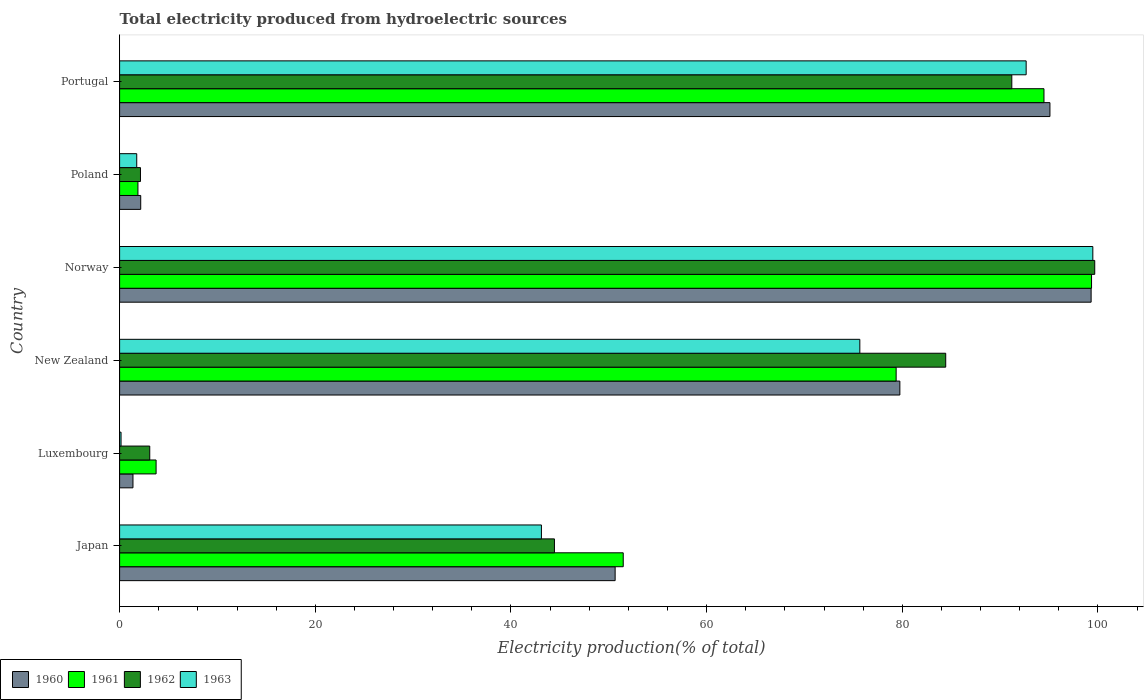How many different coloured bars are there?
Give a very brief answer. 4. How many bars are there on the 1st tick from the bottom?
Offer a very short reply. 4. What is the total electricity produced in 1960 in New Zealand?
Make the answer very short. 79.75. Across all countries, what is the maximum total electricity produced in 1961?
Keep it short and to the point. 99.34. Across all countries, what is the minimum total electricity produced in 1963?
Provide a succinct answer. 0.15. In which country was the total electricity produced in 1963 minimum?
Provide a succinct answer. Luxembourg. What is the total total electricity produced in 1960 in the graph?
Provide a short and direct response. 328.31. What is the difference between the total electricity produced in 1960 in New Zealand and that in Portugal?
Your response must be concise. -15.34. What is the difference between the total electricity produced in 1960 in Luxembourg and the total electricity produced in 1961 in Norway?
Make the answer very short. -97.98. What is the average total electricity produced in 1963 per country?
Offer a very short reply. 52.13. What is the difference between the total electricity produced in 1960 and total electricity produced in 1961 in Poland?
Your answer should be very brief. 0.28. In how many countries, is the total electricity produced in 1961 greater than 52 %?
Keep it short and to the point. 3. What is the ratio of the total electricity produced in 1962 in Japan to that in New Zealand?
Provide a short and direct response. 0.53. Is the difference between the total electricity produced in 1960 in Poland and Portugal greater than the difference between the total electricity produced in 1961 in Poland and Portugal?
Ensure brevity in your answer.  No. What is the difference between the highest and the second highest total electricity produced in 1962?
Offer a terse response. 8.48. What is the difference between the highest and the lowest total electricity produced in 1960?
Your response must be concise. 97.93. Are all the bars in the graph horizontal?
Provide a succinct answer. Yes. What is the difference between two consecutive major ticks on the X-axis?
Make the answer very short. 20. Are the values on the major ticks of X-axis written in scientific E-notation?
Keep it short and to the point. No. How many legend labels are there?
Your response must be concise. 4. How are the legend labels stacked?
Make the answer very short. Horizontal. What is the title of the graph?
Offer a terse response. Total electricity produced from hydroelectric sources. Does "1983" appear as one of the legend labels in the graph?
Offer a terse response. No. What is the label or title of the X-axis?
Ensure brevity in your answer.  Electricity production(% of total). What is the Electricity production(% of total) of 1960 in Japan?
Your answer should be compact. 50.65. What is the Electricity production(% of total) in 1961 in Japan?
Your response must be concise. 51.48. What is the Electricity production(% of total) in 1962 in Japan?
Give a very brief answer. 44.44. What is the Electricity production(% of total) of 1963 in Japan?
Give a very brief answer. 43.11. What is the Electricity production(% of total) of 1960 in Luxembourg?
Give a very brief answer. 1.37. What is the Electricity production(% of total) in 1961 in Luxembourg?
Your response must be concise. 3.73. What is the Electricity production(% of total) in 1962 in Luxembourg?
Keep it short and to the point. 3.08. What is the Electricity production(% of total) of 1963 in Luxembourg?
Provide a short and direct response. 0.15. What is the Electricity production(% of total) in 1960 in New Zealand?
Make the answer very short. 79.75. What is the Electricity production(% of total) in 1961 in New Zealand?
Your response must be concise. 79.37. What is the Electricity production(% of total) of 1962 in New Zealand?
Ensure brevity in your answer.  84.44. What is the Electricity production(% of total) in 1963 in New Zealand?
Offer a terse response. 75.66. What is the Electricity production(% of total) of 1960 in Norway?
Your answer should be compact. 99.3. What is the Electricity production(% of total) in 1961 in Norway?
Keep it short and to the point. 99.34. What is the Electricity production(% of total) of 1962 in Norway?
Provide a succinct answer. 99.67. What is the Electricity production(% of total) of 1963 in Norway?
Provide a short and direct response. 99.47. What is the Electricity production(% of total) of 1960 in Poland?
Make the answer very short. 2.16. What is the Electricity production(% of total) in 1961 in Poland?
Give a very brief answer. 1.87. What is the Electricity production(% of total) of 1962 in Poland?
Offer a terse response. 2.13. What is the Electricity production(% of total) of 1963 in Poland?
Your answer should be compact. 1.75. What is the Electricity production(% of total) of 1960 in Portugal?
Offer a very short reply. 95.09. What is the Electricity production(% of total) of 1961 in Portugal?
Keep it short and to the point. 94.48. What is the Electricity production(% of total) in 1962 in Portugal?
Give a very brief answer. 91.19. What is the Electricity production(% of total) of 1963 in Portugal?
Offer a terse response. 92.66. Across all countries, what is the maximum Electricity production(% of total) in 1960?
Your answer should be very brief. 99.3. Across all countries, what is the maximum Electricity production(% of total) of 1961?
Make the answer very short. 99.34. Across all countries, what is the maximum Electricity production(% of total) in 1962?
Your answer should be compact. 99.67. Across all countries, what is the maximum Electricity production(% of total) of 1963?
Provide a short and direct response. 99.47. Across all countries, what is the minimum Electricity production(% of total) of 1960?
Your answer should be very brief. 1.37. Across all countries, what is the minimum Electricity production(% of total) in 1961?
Your answer should be compact. 1.87. Across all countries, what is the minimum Electricity production(% of total) in 1962?
Provide a short and direct response. 2.13. Across all countries, what is the minimum Electricity production(% of total) in 1963?
Provide a short and direct response. 0.15. What is the total Electricity production(% of total) in 1960 in the graph?
Your answer should be compact. 328.31. What is the total Electricity production(% of total) of 1961 in the graph?
Keep it short and to the point. 330.28. What is the total Electricity production(% of total) of 1962 in the graph?
Give a very brief answer. 324.96. What is the total Electricity production(% of total) of 1963 in the graph?
Provide a succinct answer. 312.81. What is the difference between the Electricity production(% of total) of 1960 in Japan and that in Luxembourg?
Give a very brief answer. 49.28. What is the difference between the Electricity production(% of total) in 1961 in Japan and that in Luxembourg?
Give a very brief answer. 47.75. What is the difference between the Electricity production(% of total) of 1962 in Japan and that in Luxembourg?
Offer a terse response. 41.36. What is the difference between the Electricity production(% of total) in 1963 in Japan and that in Luxembourg?
Make the answer very short. 42.97. What is the difference between the Electricity production(% of total) in 1960 in Japan and that in New Zealand?
Give a very brief answer. -29.1. What is the difference between the Electricity production(% of total) of 1961 in Japan and that in New Zealand?
Provide a short and direct response. -27.9. What is the difference between the Electricity production(% of total) in 1962 in Japan and that in New Zealand?
Provide a succinct answer. -39.99. What is the difference between the Electricity production(% of total) in 1963 in Japan and that in New Zealand?
Offer a very short reply. -32.54. What is the difference between the Electricity production(% of total) of 1960 in Japan and that in Norway?
Your answer should be compact. -48.65. What is the difference between the Electricity production(% of total) in 1961 in Japan and that in Norway?
Ensure brevity in your answer.  -47.87. What is the difference between the Electricity production(% of total) of 1962 in Japan and that in Norway?
Provide a short and direct response. -55.23. What is the difference between the Electricity production(% of total) in 1963 in Japan and that in Norway?
Ensure brevity in your answer.  -56.36. What is the difference between the Electricity production(% of total) in 1960 in Japan and that in Poland?
Ensure brevity in your answer.  48.49. What is the difference between the Electricity production(% of total) in 1961 in Japan and that in Poland?
Offer a terse response. 49.6. What is the difference between the Electricity production(% of total) in 1962 in Japan and that in Poland?
Offer a terse response. 42.31. What is the difference between the Electricity production(% of total) of 1963 in Japan and that in Poland?
Give a very brief answer. 41.36. What is the difference between the Electricity production(% of total) of 1960 in Japan and that in Portugal?
Give a very brief answer. -44.44. What is the difference between the Electricity production(% of total) in 1961 in Japan and that in Portugal?
Offer a terse response. -43. What is the difference between the Electricity production(% of total) of 1962 in Japan and that in Portugal?
Offer a terse response. -46.75. What is the difference between the Electricity production(% of total) in 1963 in Japan and that in Portugal?
Your answer should be compact. -49.55. What is the difference between the Electricity production(% of total) of 1960 in Luxembourg and that in New Zealand?
Provide a short and direct response. -78.38. What is the difference between the Electricity production(% of total) of 1961 in Luxembourg and that in New Zealand?
Offer a terse response. -75.64. What is the difference between the Electricity production(% of total) in 1962 in Luxembourg and that in New Zealand?
Provide a succinct answer. -81.36. What is the difference between the Electricity production(% of total) in 1963 in Luxembourg and that in New Zealand?
Ensure brevity in your answer.  -75.51. What is the difference between the Electricity production(% of total) in 1960 in Luxembourg and that in Norway?
Provide a succinct answer. -97.93. What is the difference between the Electricity production(% of total) of 1961 in Luxembourg and that in Norway?
Offer a terse response. -95.61. What is the difference between the Electricity production(% of total) in 1962 in Luxembourg and that in Norway?
Your answer should be very brief. -96.59. What is the difference between the Electricity production(% of total) of 1963 in Luxembourg and that in Norway?
Offer a terse response. -99.33. What is the difference between the Electricity production(% of total) in 1960 in Luxembourg and that in Poland?
Your response must be concise. -0.79. What is the difference between the Electricity production(% of total) in 1961 in Luxembourg and that in Poland?
Ensure brevity in your answer.  1.86. What is the difference between the Electricity production(% of total) of 1962 in Luxembourg and that in Poland?
Provide a succinct answer. 0.95. What is the difference between the Electricity production(% of total) in 1963 in Luxembourg and that in Poland?
Ensure brevity in your answer.  -1.6. What is the difference between the Electricity production(% of total) of 1960 in Luxembourg and that in Portugal?
Your answer should be very brief. -93.72. What is the difference between the Electricity production(% of total) in 1961 in Luxembourg and that in Portugal?
Offer a very short reply. -90.75. What is the difference between the Electricity production(% of total) of 1962 in Luxembourg and that in Portugal?
Offer a very short reply. -88.11. What is the difference between the Electricity production(% of total) of 1963 in Luxembourg and that in Portugal?
Offer a terse response. -92.51. What is the difference between the Electricity production(% of total) in 1960 in New Zealand and that in Norway?
Your answer should be very brief. -19.55. What is the difference between the Electricity production(% of total) in 1961 in New Zealand and that in Norway?
Provide a short and direct response. -19.97. What is the difference between the Electricity production(% of total) in 1962 in New Zealand and that in Norway?
Offer a terse response. -15.23. What is the difference between the Electricity production(% of total) in 1963 in New Zealand and that in Norway?
Your answer should be very brief. -23.82. What is the difference between the Electricity production(% of total) in 1960 in New Zealand and that in Poland?
Your response must be concise. 77.59. What is the difference between the Electricity production(% of total) in 1961 in New Zealand and that in Poland?
Ensure brevity in your answer.  77.5. What is the difference between the Electricity production(% of total) of 1962 in New Zealand and that in Poland?
Keep it short and to the point. 82.31. What is the difference between the Electricity production(% of total) in 1963 in New Zealand and that in Poland?
Provide a succinct answer. 73.91. What is the difference between the Electricity production(% of total) of 1960 in New Zealand and that in Portugal?
Offer a terse response. -15.34. What is the difference between the Electricity production(% of total) in 1961 in New Zealand and that in Portugal?
Make the answer very short. -15.11. What is the difference between the Electricity production(% of total) of 1962 in New Zealand and that in Portugal?
Ensure brevity in your answer.  -6.75. What is the difference between the Electricity production(% of total) in 1963 in New Zealand and that in Portugal?
Your answer should be very brief. -17. What is the difference between the Electricity production(% of total) in 1960 in Norway and that in Poland?
Provide a succinct answer. 97.14. What is the difference between the Electricity production(% of total) of 1961 in Norway and that in Poland?
Provide a succinct answer. 97.47. What is the difference between the Electricity production(% of total) of 1962 in Norway and that in Poland?
Keep it short and to the point. 97.54. What is the difference between the Electricity production(% of total) of 1963 in Norway and that in Poland?
Provide a short and direct response. 97.72. What is the difference between the Electricity production(% of total) of 1960 in Norway and that in Portugal?
Offer a very short reply. 4.21. What is the difference between the Electricity production(% of total) of 1961 in Norway and that in Portugal?
Make the answer very short. 4.86. What is the difference between the Electricity production(% of total) in 1962 in Norway and that in Portugal?
Your answer should be compact. 8.48. What is the difference between the Electricity production(% of total) of 1963 in Norway and that in Portugal?
Keep it short and to the point. 6.81. What is the difference between the Electricity production(% of total) of 1960 in Poland and that in Portugal?
Your answer should be compact. -92.93. What is the difference between the Electricity production(% of total) in 1961 in Poland and that in Portugal?
Your response must be concise. -92.61. What is the difference between the Electricity production(% of total) in 1962 in Poland and that in Portugal?
Your response must be concise. -89.06. What is the difference between the Electricity production(% of total) in 1963 in Poland and that in Portugal?
Keep it short and to the point. -90.91. What is the difference between the Electricity production(% of total) of 1960 in Japan and the Electricity production(% of total) of 1961 in Luxembourg?
Provide a short and direct response. 46.92. What is the difference between the Electricity production(% of total) of 1960 in Japan and the Electricity production(% of total) of 1962 in Luxembourg?
Your response must be concise. 47.57. What is the difference between the Electricity production(% of total) of 1960 in Japan and the Electricity production(% of total) of 1963 in Luxembourg?
Your answer should be very brief. 50.5. What is the difference between the Electricity production(% of total) of 1961 in Japan and the Electricity production(% of total) of 1962 in Luxembourg?
Keep it short and to the point. 48.39. What is the difference between the Electricity production(% of total) in 1961 in Japan and the Electricity production(% of total) in 1963 in Luxembourg?
Provide a succinct answer. 51.33. What is the difference between the Electricity production(% of total) in 1962 in Japan and the Electricity production(% of total) in 1963 in Luxembourg?
Make the answer very short. 44.3. What is the difference between the Electricity production(% of total) of 1960 in Japan and the Electricity production(% of total) of 1961 in New Zealand?
Your answer should be compact. -28.72. What is the difference between the Electricity production(% of total) in 1960 in Japan and the Electricity production(% of total) in 1962 in New Zealand?
Keep it short and to the point. -33.79. What is the difference between the Electricity production(% of total) of 1960 in Japan and the Electricity production(% of total) of 1963 in New Zealand?
Your answer should be compact. -25.01. What is the difference between the Electricity production(% of total) of 1961 in Japan and the Electricity production(% of total) of 1962 in New Zealand?
Offer a very short reply. -32.96. What is the difference between the Electricity production(% of total) in 1961 in Japan and the Electricity production(% of total) in 1963 in New Zealand?
Offer a very short reply. -24.18. What is the difference between the Electricity production(% of total) in 1962 in Japan and the Electricity production(% of total) in 1963 in New Zealand?
Give a very brief answer. -31.21. What is the difference between the Electricity production(% of total) in 1960 in Japan and the Electricity production(% of total) in 1961 in Norway?
Your answer should be compact. -48.69. What is the difference between the Electricity production(% of total) of 1960 in Japan and the Electricity production(% of total) of 1962 in Norway?
Ensure brevity in your answer.  -49.02. What is the difference between the Electricity production(% of total) in 1960 in Japan and the Electricity production(% of total) in 1963 in Norway?
Provide a short and direct response. -48.83. What is the difference between the Electricity production(% of total) in 1961 in Japan and the Electricity production(% of total) in 1962 in Norway?
Ensure brevity in your answer.  -48.19. What is the difference between the Electricity production(% of total) in 1961 in Japan and the Electricity production(% of total) in 1963 in Norway?
Give a very brief answer. -48. What is the difference between the Electricity production(% of total) of 1962 in Japan and the Electricity production(% of total) of 1963 in Norway?
Your response must be concise. -55.03. What is the difference between the Electricity production(% of total) in 1960 in Japan and the Electricity production(% of total) in 1961 in Poland?
Offer a very short reply. 48.78. What is the difference between the Electricity production(% of total) of 1960 in Japan and the Electricity production(% of total) of 1962 in Poland?
Keep it short and to the point. 48.52. What is the difference between the Electricity production(% of total) in 1960 in Japan and the Electricity production(% of total) in 1963 in Poland?
Provide a succinct answer. 48.9. What is the difference between the Electricity production(% of total) of 1961 in Japan and the Electricity production(% of total) of 1962 in Poland?
Your response must be concise. 49.34. What is the difference between the Electricity production(% of total) of 1961 in Japan and the Electricity production(% of total) of 1963 in Poland?
Provide a succinct answer. 49.72. What is the difference between the Electricity production(% of total) of 1962 in Japan and the Electricity production(% of total) of 1963 in Poland?
Provide a short and direct response. 42.69. What is the difference between the Electricity production(% of total) of 1960 in Japan and the Electricity production(% of total) of 1961 in Portugal?
Provide a short and direct response. -43.83. What is the difference between the Electricity production(% of total) of 1960 in Japan and the Electricity production(% of total) of 1962 in Portugal?
Make the answer very short. -40.54. What is the difference between the Electricity production(% of total) in 1960 in Japan and the Electricity production(% of total) in 1963 in Portugal?
Give a very brief answer. -42.01. What is the difference between the Electricity production(% of total) in 1961 in Japan and the Electricity production(% of total) in 1962 in Portugal?
Make the answer very short. -39.72. What is the difference between the Electricity production(% of total) in 1961 in Japan and the Electricity production(% of total) in 1963 in Portugal?
Provide a short and direct response. -41.18. What is the difference between the Electricity production(% of total) of 1962 in Japan and the Electricity production(% of total) of 1963 in Portugal?
Provide a short and direct response. -48.22. What is the difference between the Electricity production(% of total) in 1960 in Luxembourg and the Electricity production(% of total) in 1961 in New Zealand?
Ensure brevity in your answer.  -78.01. What is the difference between the Electricity production(% of total) in 1960 in Luxembourg and the Electricity production(% of total) in 1962 in New Zealand?
Provide a succinct answer. -83.07. What is the difference between the Electricity production(% of total) in 1960 in Luxembourg and the Electricity production(% of total) in 1963 in New Zealand?
Provide a succinct answer. -74.29. What is the difference between the Electricity production(% of total) in 1961 in Luxembourg and the Electricity production(% of total) in 1962 in New Zealand?
Offer a terse response. -80.71. What is the difference between the Electricity production(% of total) of 1961 in Luxembourg and the Electricity production(% of total) of 1963 in New Zealand?
Offer a terse response. -71.93. What is the difference between the Electricity production(% of total) in 1962 in Luxembourg and the Electricity production(% of total) in 1963 in New Zealand?
Offer a terse response. -72.58. What is the difference between the Electricity production(% of total) in 1960 in Luxembourg and the Electricity production(% of total) in 1961 in Norway?
Keep it short and to the point. -97.98. What is the difference between the Electricity production(% of total) of 1960 in Luxembourg and the Electricity production(% of total) of 1962 in Norway?
Make the answer very short. -98.3. What is the difference between the Electricity production(% of total) of 1960 in Luxembourg and the Electricity production(% of total) of 1963 in Norway?
Your answer should be very brief. -98.11. What is the difference between the Electricity production(% of total) of 1961 in Luxembourg and the Electricity production(% of total) of 1962 in Norway?
Provide a short and direct response. -95.94. What is the difference between the Electricity production(% of total) in 1961 in Luxembourg and the Electricity production(% of total) in 1963 in Norway?
Offer a terse response. -95.74. What is the difference between the Electricity production(% of total) in 1962 in Luxembourg and the Electricity production(% of total) in 1963 in Norway?
Your answer should be very brief. -96.39. What is the difference between the Electricity production(% of total) in 1960 in Luxembourg and the Electricity production(% of total) in 1961 in Poland?
Your answer should be compact. -0.51. What is the difference between the Electricity production(% of total) of 1960 in Luxembourg and the Electricity production(% of total) of 1962 in Poland?
Provide a succinct answer. -0.77. What is the difference between the Electricity production(% of total) of 1960 in Luxembourg and the Electricity production(% of total) of 1963 in Poland?
Ensure brevity in your answer.  -0.39. What is the difference between the Electricity production(% of total) in 1961 in Luxembourg and the Electricity production(% of total) in 1962 in Poland?
Your answer should be compact. 1.6. What is the difference between the Electricity production(% of total) in 1961 in Luxembourg and the Electricity production(% of total) in 1963 in Poland?
Make the answer very short. 1.98. What is the difference between the Electricity production(% of total) of 1962 in Luxembourg and the Electricity production(% of total) of 1963 in Poland?
Offer a terse response. 1.33. What is the difference between the Electricity production(% of total) of 1960 in Luxembourg and the Electricity production(% of total) of 1961 in Portugal?
Provide a short and direct response. -93.11. What is the difference between the Electricity production(% of total) of 1960 in Luxembourg and the Electricity production(% of total) of 1962 in Portugal?
Provide a short and direct response. -89.83. What is the difference between the Electricity production(% of total) in 1960 in Luxembourg and the Electricity production(% of total) in 1963 in Portugal?
Offer a very short reply. -91.29. What is the difference between the Electricity production(% of total) of 1961 in Luxembourg and the Electricity production(% of total) of 1962 in Portugal?
Give a very brief answer. -87.46. What is the difference between the Electricity production(% of total) in 1961 in Luxembourg and the Electricity production(% of total) in 1963 in Portugal?
Offer a terse response. -88.93. What is the difference between the Electricity production(% of total) of 1962 in Luxembourg and the Electricity production(% of total) of 1963 in Portugal?
Your response must be concise. -89.58. What is the difference between the Electricity production(% of total) of 1960 in New Zealand and the Electricity production(% of total) of 1961 in Norway?
Your answer should be very brief. -19.59. What is the difference between the Electricity production(% of total) of 1960 in New Zealand and the Electricity production(% of total) of 1962 in Norway?
Ensure brevity in your answer.  -19.92. What is the difference between the Electricity production(% of total) of 1960 in New Zealand and the Electricity production(% of total) of 1963 in Norway?
Your answer should be very brief. -19.72. What is the difference between the Electricity production(% of total) in 1961 in New Zealand and the Electricity production(% of total) in 1962 in Norway?
Provide a succinct answer. -20.3. What is the difference between the Electricity production(% of total) in 1961 in New Zealand and the Electricity production(% of total) in 1963 in Norway?
Ensure brevity in your answer.  -20.1. What is the difference between the Electricity production(% of total) in 1962 in New Zealand and the Electricity production(% of total) in 1963 in Norway?
Offer a terse response. -15.04. What is the difference between the Electricity production(% of total) in 1960 in New Zealand and the Electricity production(% of total) in 1961 in Poland?
Keep it short and to the point. 77.88. What is the difference between the Electricity production(% of total) of 1960 in New Zealand and the Electricity production(% of total) of 1962 in Poland?
Provide a succinct answer. 77.62. What is the difference between the Electricity production(% of total) in 1960 in New Zealand and the Electricity production(% of total) in 1963 in Poland?
Offer a terse response. 78. What is the difference between the Electricity production(% of total) of 1961 in New Zealand and the Electricity production(% of total) of 1962 in Poland?
Make the answer very short. 77.24. What is the difference between the Electricity production(% of total) of 1961 in New Zealand and the Electricity production(% of total) of 1963 in Poland?
Give a very brief answer. 77.62. What is the difference between the Electricity production(% of total) of 1962 in New Zealand and the Electricity production(% of total) of 1963 in Poland?
Your answer should be compact. 82.69. What is the difference between the Electricity production(% of total) in 1960 in New Zealand and the Electricity production(% of total) in 1961 in Portugal?
Make the answer very short. -14.73. What is the difference between the Electricity production(% of total) of 1960 in New Zealand and the Electricity production(% of total) of 1962 in Portugal?
Your answer should be very brief. -11.44. What is the difference between the Electricity production(% of total) of 1960 in New Zealand and the Electricity production(% of total) of 1963 in Portugal?
Your response must be concise. -12.91. What is the difference between the Electricity production(% of total) of 1961 in New Zealand and the Electricity production(% of total) of 1962 in Portugal?
Provide a short and direct response. -11.82. What is the difference between the Electricity production(% of total) of 1961 in New Zealand and the Electricity production(% of total) of 1963 in Portugal?
Your response must be concise. -13.29. What is the difference between the Electricity production(% of total) in 1962 in New Zealand and the Electricity production(% of total) in 1963 in Portugal?
Offer a very short reply. -8.22. What is the difference between the Electricity production(% of total) in 1960 in Norway and the Electricity production(% of total) in 1961 in Poland?
Provide a succinct answer. 97.43. What is the difference between the Electricity production(% of total) of 1960 in Norway and the Electricity production(% of total) of 1962 in Poland?
Offer a terse response. 97.17. What is the difference between the Electricity production(% of total) in 1960 in Norway and the Electricity production(% of total) in 1963 in Poland?
Ensure brevity in your answer.  97.55. What is the difference between the Electricity production(% of total) in 1961 in Norway and the Electricity production(% of total) in 1962 in Poland?
Make the answer very short. 97.21. What is the difference between the Electricity production(% of total) of 1961 in Norway and the Electricity production(% of total) of 1963 in Poland?
Provide a succinct answer. 97.59. What is the difference between the Electricity production(% of total) of 1962 in Norway and the Electricity production(% of total) of 1963 in Poland?
Your response must be concise. 97.92. What is the difference between the Electricity production(% of total) in 1960 in Norway and the Electricity production(% of total) in 1961 in Portugal?
Keep it short and to the point. 4.82. What is the difference between the Electricity production(% of total) in 1960 in Norway and the Electricity production(% of total) in 1962 in Portugal?
Your answer should be very brief. 8.11. What is the difference between the Electricity production(% of total) in 1960 in Norway and the Electricity production(% of total) in 1963 in Portugal?
Ensure brevity in your answer.  6.64. What is the difference between the Electricity production(% of total) of 1961 in Norway and the Electricity production(% of total) of 1962 in Portugal?
Keep it short and to the point. 8.15. What is the difference between the Electricity production(% of total) of 1961 in Norway and the Electricity production(% of total) of 1963 in Portugal?
Give a very brief answer. 6.68. What is the difference between the Electricity production(% of total) in 1962 in Norway and the Electricity production(% of total) in 1963 in Portugal?
Give a very brief answer. 7.01. What is the difference between the Electricity production(% of total) of 1960 in Poland and the Electricity production(% of total) of 1961 in Portugal?
Provide a succinct answer. -92.32. What is the difference between the Electricity production(% of total) of 1960 in Poland and the Electricity production(% of total) of 1962 in Portugal?
Make the answer very short. -89.03. What is the difference between the Electricity production(% of total) in 1960 in Poland and the Electricity production(% of total) in 1963 in Portugal?
Offer a terse response. -90.5. What is the difference between the Electricity production(% of total) of 1961 in Poland and the Electricity production(% of total) of 1962 in Portugal?
Make the answer very short. -89.32. What is the difference between the Electricity production(% of total) of 1961 in Poland and the Electricity production(% of total) of 1963 in Portugal?
Offer a very short reply. -90.79. What is the difference between the Electricity production(% of total) of 1962 in Poland and the Electricity production(% of total) of 1963 in Portugal?
Your answer should be very brief. -90.53. What is the average Electricity production(% of total) in 1960 per country?
Make the answer very short. 54.72. What is the average Electricity production(% of total) in 1961 per country?
Give a very brief answer. 55.05. What is the average Electricity production(% of total) of 1962 per country?
Offer a terse response. 54.16. What is the average Electricity production(% of total) of 1963 per country?
Offer a terse response. 52.13. What is the difference between the Electricity production(% of total) of 1960 and Electricity production(% of total) of 1961 in Japan?
Provide a succinct answer. -0.83. What is the difference between the Electricity production(% of total) in 1960 and Electricity production(% of total) in 1962 in Japan?
Give a very brief answer. 6.2. What is the difference between the Electricity production(% of total) of 1960 and Electricity production(% of total) of 1963 in Japan?
Offer a terse response. 7.54. What is the difference between the Electricity production(% of total) in 1961 and Electricity production(% of total) in 1962 in Japan?
Ensure brevity in your answer.  7.03. What is the difference between the Electricity production(% of total) in 1961 and Electricity production(% of total) in 1963 in Japan?
Your response must be concise. 8.36. What is the difference between the Electricity production(% of total) of 1962 and Electricity production(% of total) of 1963 in Japan?
Give a very brief answer. 1.33. What is the difference between the Electricity production(% of total) in 1960 and Electricity production(% of total) in 1961 in Luxembourg?
Provide a succinct answer. -2.36. What is the difference between the Electricity production(% of total) of 1960 and Electricity production(% of total) of 1962 in Luxembourg?
Ensure brevity in your answer.  -1.72. What is the difference between the Electricity production(% of total) in 1960 and Electricity production(% of total) in 1963 in Luxembourg?
Provide a short and direct response. 1.22. What is the difference between the Electricity production(% of total) in 1961 and Electricity production(% of total) in 1962 in Luxembourg?
Your response must be concise. 0.65. What is the difference between the Electricity production(% of total) in 1961 and Electricity production(% of total) in 1963 in Luxembourg?
Keep it short and to the point. 3.58. What is the difference between the Electricity production(% of total) of 1962 and Electricity production(% of total) of 1963 in Luxembourg?
Your answer should be very brief. 2.93. What is the difference between the Electricity production(% of total) in 1960 and Electricity production(% of total) in 1961 in New Zealand?
Ensure brevity in your answer.  0.38. What is the difference between the Electricity production(% of total) in 1960 and Electricity production(% of total) in 1962 in New Zealand?
Provide a short and direct response. -4.69. What is the difference between the Electricity production(% of total) of 1960 and Electricity production(% of total) of 1963 in New Zealand?
Make the answer very short. 4.09. What is the difference between the Electricity production(% of total) of 1961 and Electricity production(% of total) of 1962 in New Zealand?
Ensure brevity in your answer.  -5.07. What is the difference between the Electricity production(% of total) in 1961 and Electricity production(% of total) in 1963 in New Zealand?
Make the answer very short. 3.71. What is the difference between the Electricity production(% of total) in 1962 and Electricity production(% of total) in 1963 in New Zealand?
Your response must be concise. 8.78. What is the difference between the Electricity production(% of total) of 1960 and Electricity production(% of total) of 1961 in Norway?
Give a very brief answer. -0.04. What is the difference between the Electricity production(% of total) of 1960 and Electricity production(% of total) of 1962 in Norway?
Offer a terse response. -0.37. What is the difference between the Electricity production(% of total) of 1960 and Electricity production(% of total) of 1963 in Norway?
Offer a terse response. -0.17. What is the difference between the Electricity production(% of total) of 1961 and Electricity production(% of total) of 1962 in Norway?
Offer a terse response. -0.33. What is the difference between the Electricity production(% of total) of 1961 and Electricity production(% of total) of 1963 in Norway?
Offer a terse response. -0.13. What is the difference between the Electricity production(% of total) in 1962 and Electricity production(% of total) in 1963 in Norway?
Provide a short and direct response. 0.19. What is the difference between the Electricity production(% of total) in 1960 and Electricity production(% of total) in 1961 in Poland?
Your response must be concise. 0.28. What is the difference between the Electricity production(% of total) in 1960 and Electricity production(% of total) in 1962 in Poland?
Your answer should be very brief. 0.03. What is the difference between the Electricity production(% of total) in 1960 and Electricity production(% of total) in 1963 in Poland?
Your response must be concise. 0.41. What is the difference between the Electricity production(% of total) of 1961 and Electricity production(% of total) of 1962 in Poland?
Keep it short and to the point. -0.26. What is the difference between the Electricity production(% of total) in 1961 and Electricity production(% of total) in 1963 in Poland?
Your answer should be compact. 0.12. What is the difference between the Electricity production(% of total) of 1962 and Electricity production(% of total) of 1963 in Poland?
Provide a short and direct response. 0.38. What is the difference between the Electricity production(% of total) of 1960 and Electricity production(% of total) of 1961 in Portugal?
Keep it short and to the point. 0.61. What is the difference between the Electricity production(% of total) of 1960 and Electricity production(% of total) of 1962 in Portugal?
Offer a very short reply. 3.9. What is the difference between the Electricity production(% of total) in 1960 and Electricity production(% of total) in 1963 in Portugal?
Provide a succinct answer. 2.43. What is the difference between the Electricity production(% of total) in 1961 and Electricity production(% of total) in 1962 in Portugal?
Give a very brief answer. 3.29. What is the difference between the Electricity production(% of total) in 1961 and Electricity production(% of total) in 1963 in Portugal?
Ensure brevity in your answer.  1.82. What is the difference between the Electricity production(% of total) of 1962 and Electricity production(% of total) of 1963 in Portugal?
Keep it short and to the point. -1.47. What is the ratio of the Electricity production(% of total) in 1960 in Japan to that in Luxembourg?
Ensure brevity in your answer.  37.08. What is the ratio of the Electricity production(% of total) in 1961 in Japan to that in Luxembourg?
Keep it short and to the point. 13.8. What is the ratio of the Electricity production(% of total) of 1962 in Japan to that in Luxembourg?
Give a very brief answer. 14.42. What is the ratio of the Electricity production(% of total) of 1963 in Japan to that in Luxembourg?
Provide a short and direct response. 292.1. What is the ratio of the Electricity production(% of total) in 1960 in Japan to that in New Zealand?
Your answer should be very brief. 0.64. What is the ratio of the Electricity production(% of total) in 1961 in Japan to that in New Zealand?
Make the answer very short. 0.65. What is the ratio of the Electricity production(% of total) in 1962 in Japan to that in New Zealand?
Offer a terse response. 0.53. What is the ratio of the Electricity production(% of total) in 1963 in Japan to that in New Zealand?
Make the answer very short. 0.57. What is the ratio of the Electricity production(% of total) in 1960 in Japan to that in Norway?
Make the answer very short. 0.51. What is the ratio of the Electricity production(% of total) in 1961 in Japan to that in Norway?
Your answer should be very brief. 0.52. What is the ratio of the Electricity production(% of total) of 1962 in Japan to that in Norway?
Keep it short and to the point. 0.45. What is the ratio of the Electricity production(% of total) in 1963 in Japan to that in Norway?
Give a very brief answer. 0.43. What is the ratio of the Electricity production(% of total) in 1960 in Japan to that in Poland?
Offer a terse response. 23.47. What is the ratio of the Electricity production(% of total) of 1961 in Japan to that in Poland?
Keep it short and to the point. 27.48. What is the ratio of the Electricity production(% of total) in 1962 in Japan to that in Poland?
Keep it short and to the point. 20.85. What is the ratio of the Electricity production(% of total) of 1963 in Japan to that in Poland?
Offer a terse response. 24.62. What is the ratio of the Electricity production(% of total) in 1960 in Japan to that in Portugal?
Provide a succinct answer. 0.53. What is the ratio of the Electricity production(% of total) in 1961 in Japan to that in Portugal?
Provide a succinct answer. 0.54. What is the ratio of the Electricity production(% of total) in 1962 in Japan to that in Portugal?
Offer a terse response. 0.49. What is the ratio of the Electricity production(% of total) of 1963 in Japan to that in Portugal?
Provide a short and direct response. 0.47. What is the ratio of the Electricity production(% of total) in 1960 in Luxembourg to that in New Zealand?
Your answer should be compact. 0.02. What is the ratio of the Electricity production(% of total) in 1961 in Luxembourg to that in New Zealand?
Offer a very short reply. 0.05. What is the ratio of the Electricity production(% of total) of 1962 in Luxembourg to that in New Zealand?
Offer a very short reply. 0.04. What is the ratio of the Electricity production(% of total) in 1963 in Luxembourg to that in New Zealand?
Make the answer very short. 0. What is the ratio of the Electricity production(% of total) of 1960 in Luxembourg to that in Norway?
Give a very brief answer. 0.01. What is the ratio of the Electricity production(% of total) of 1961 in Luxembourg to that in Norway?
Your answer should be very brief. 0.04. What is the ratio of the Electricity production(% of total) in 1962 in Luxembourg to that in Norway?
Provide a succinct answer. 0.03. What is the ratio of the Electricity production(% of total) of 1963 in Luxembourg to that in Norway?
Your response must be concise. 0. What is the ratio of the Electricity production(% of total) in 1960 in Luxembourg to that in Poland?
Offer a very short reply. 0.63. What is the ratio of the Electricity production(% of total) of 1961 in Luxembourg to that in Poland?
Make the answer very short. 1.99. What is the ratio of the Electricity production(% of total) of 1962 in Luxembourg to that in Poland?
Keep it short and to the point. 1.45. What is the ratio of the Electricity production(% of total) of 1963 in Luxembourg to that in Poland?
Provide a short and direct response. 0.08. What is the ratio of the Electricity production(% of total) of 1960 in Luxembourg to that in Portugal?
Make the answer very short. 0.01. What is the ratio of the Electricity production(% of total) in 1961 in Luxembourg to that in Portugal?
Provide a short and direct response. 0.04. What is the ratio of the Electricity production(% of total) in 1962 in Luxembourg to that in Portugal?
Provide a succinct answer. 0.03. What is the ratio of the Electricity production(% of total) in 1963 in Luxembourg to that in Portugal?
Keep it short and to the point. 0. What is the ratio of the Electricity production(% of total) in 1960 in New Zealand to that in Norway?
Offer a very short reply. 0.8. What is the ratio of the Electricity production(% of total) of 1961 in New Zealand to that in Norway?
Give a very brief answer. 0.8. What is the ratio of the Electricity production(% of total) in 1962 in New Zealand to that in Norway?
Your response must be concise. 0.85. What is the ratio of the Electricity production(% of total) of 1963 in New Zealand to that in Norway?
Make the answer very short. 0.76. What is the ratio of the Electricity production(% of total) in 1960 in New Zealand to that in Poland?
Provide a succinct answer. 36.95. What is the ratio of the Electricity production(% of total) in 1961 in New Zealand to that in Poland?
Make the answer very short. 42.37. What is the ratio of the Electricity production(% of total) of 1962 in New Zealand to that in Poland?
Offer a very short reply. 39.6. What is the ratio of the Electricity production(% of total) of 1963 in New Zealand to that in Poland?
Your response must be concise. 43.2. What is the ratio of the Electricity production(% of total) in 1960 in New Zealand to that in Portugal?
Your answer should be very brief. 0.84. What is the ratio of the Electricity production(% of total) of 1961 in New Zealand to that in Portugal?
Provide a succinct answer. 0.84. What is the ratio of the Electricity production(% of total) of 1962 in New Zealand to that in Portugal?
Your answer should be very brief. 0.93. What is the ratio of the Electricity production(% of total) of 1963 in New Zealand to that in Portugal?
Your answer should be very brief. 0.82. What is the ratio of the Electricity production(% of total) in 1960 in Norway to that in Poland?
Offer a terse response. 46.01. What is the ratio of the Electricity production(% of total) of 1961 in Norway to that in Poland?
Offer a very short reply. 53.03. What is the ratio of the Electricity production(% of total) of 1962 in Norway to that in Poland?
Make the answer very short. 46.75. What is the ratio of the Electricity production(% of total) of 1963 in Norway to that in Poland?
Make the answer very short. 56.8. What is the ratio of the Electricity production(% of total) of 1960 in Norway to that in Portugal?
Provide a succinct answer. 1.04. What is the ratio of the Electricity production(% of total) in 1961 in Norway to that in Portugal?
Your response must be concise. 1.05. What is the ratio of the Electricity production(% of total) in 1962 in Norway to that in Portugal?
Provide a succinct answer. 1.09. What is the ratio of the Electricity production(% of total) of 1963 in Norway to that in Portugal?
Your response must be concise. 1.07. What is the ratio of the Electricity production(% of total) of 1960 in Poland to that in Portugal?
Your answer should be very brief. 0.02. What is the ratio of the Electricity production(% of total) in 1961 in Poland to that in Portugal?
Your answer should be compact. 0.02. What is the ratio of the Electricity production(% of total) of 1962 in Poland to that in Portugal?
Give a very brief answer. 0.02. What is the ratio of the Electricity production(% of total) in 1963 in Poland to that in Portugal?
Provide a short and direct response. 0.02. What is the difference between the highest and the second highest Electricity production(% of total) in 1960?
Give a very brief answer. 4.21. What is the difference between the highest and the second highest Electricity production(% of total) in 1961?
Offer a terse response. 4.86. What is the difference between the highest and the second highest Electricity production(% of total) in 1962?
Provide a succinct answer. 8.48. What is the difference between the highest and the second highest Electricity production(% of total) of 1963?
Your answer should be compact. 6.81. What is the difference between the highest and the lowest Electricity production(% of total) of 1960?
Your response must be concise. 97.93. What is the difference between the highest and the lowest Electricity production(% of total) of 1961?
Offer a very short reply. 97.47. What is the difference between the highest and the lowest Electricity production(% of total) in 1962?
Your response must be concise. 97.54. What is the difference between the highest and the lowest Electricity production(% of total) of 1963?
Your response must be concise. 99.33. 